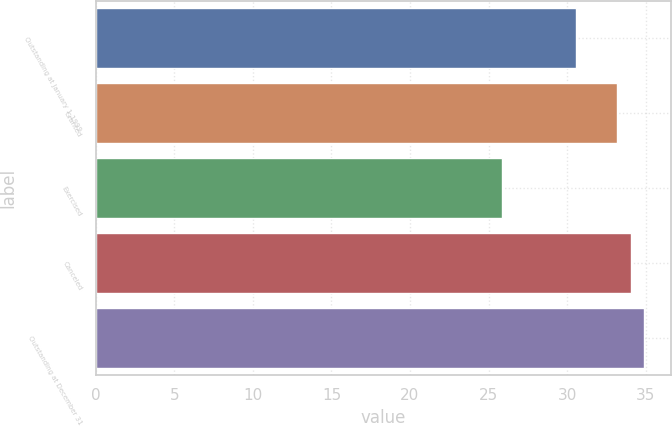Convert chart to OTSL. <chart><loc_0><loc_0><loc_500><loc_500><bar_chart><fcel>Outstanding at January 1 1999<fcel>Granted<fcel>Exercised<fcel>Canceled<fcel>Outstanding at December 31<nl><fcel>30.58<fcel>33.2<fcel>25.87<fcel>34.04<fcel>34.88<nl></chart> 